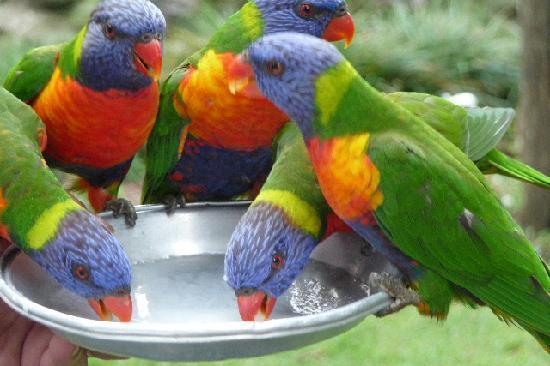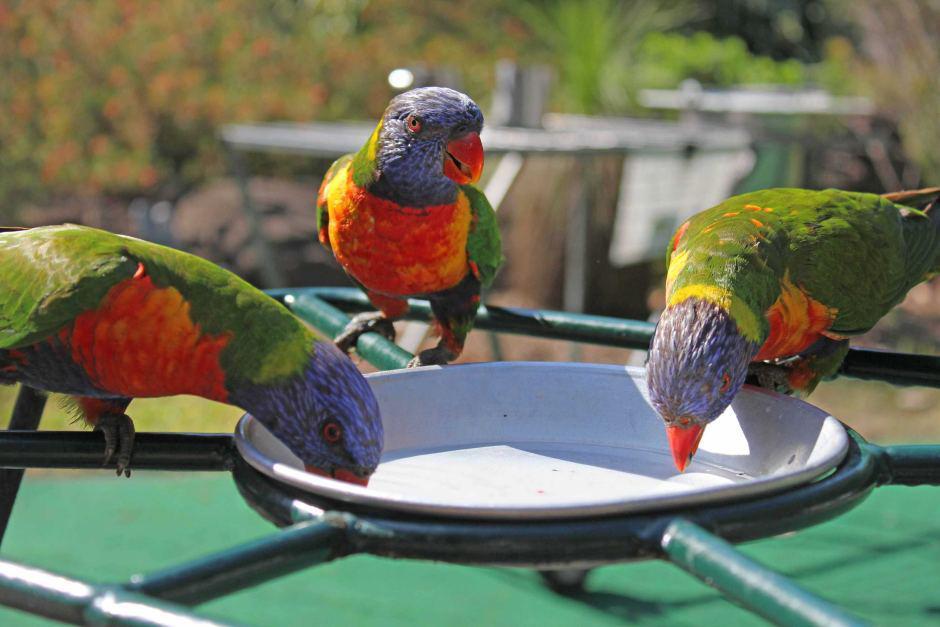The first image is the image on the left, the second image is the image on the right. Evaluate the accuracy of this statement regarding the images: "birds are standing on a green platform with a bowl in the center on a blacktop sidewalk". Is it true? Answer yes or no. No. The first image is the image on the left, the second image is the image on the right. Considering the images on both sides, is "The birds are only drinking water in one of the iages." valid? Answer yes or no. No. 